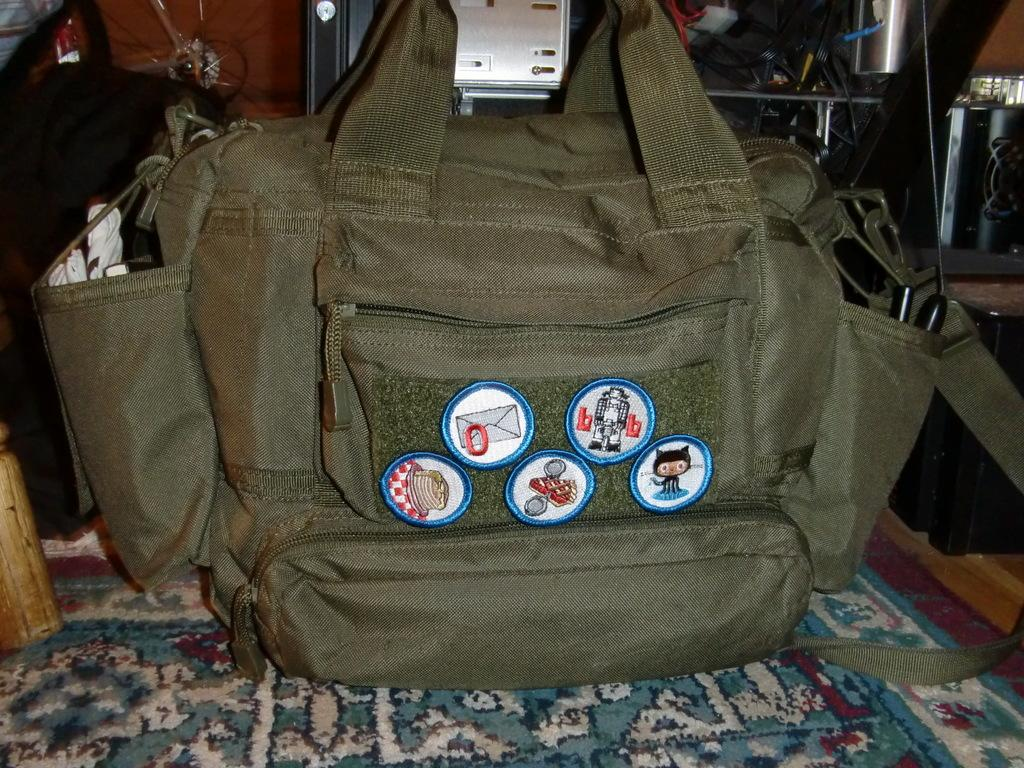What object is present in the image? There is a bag in the image. Where is the bag located? The bag is on a carpet. What type of pollution can be seen in the image? There is no pollution present in the image; it only features a bag on a carpet. Who owns the property in the image? There is no indication of property ownership in the image, as it only shows a bag on a carpet. 